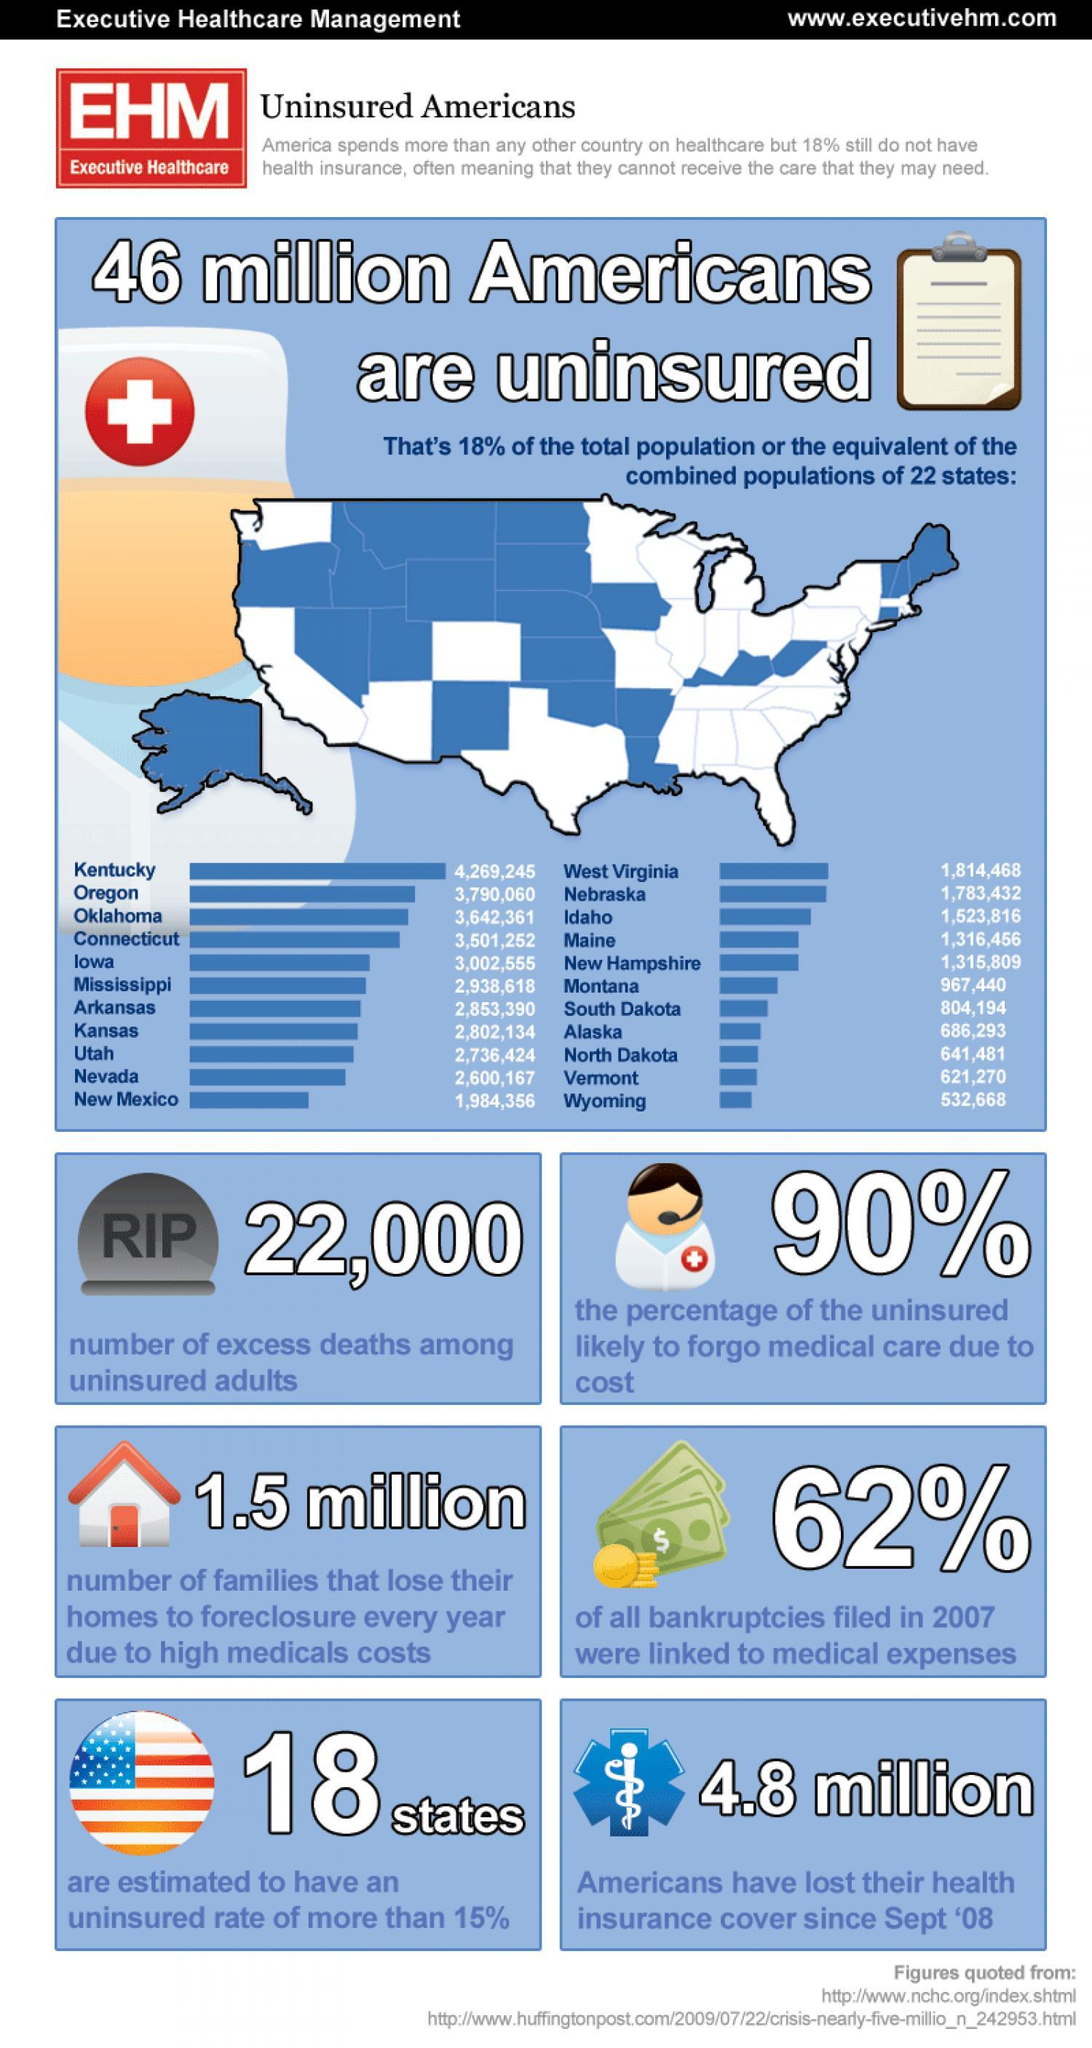what percentage uninsured will not likely forgo medical care due to cost
Answer the question with a short phrase. 10 how many states have insured rate of less than 85% 18 what is the population of wyoming and vermont 1153938 